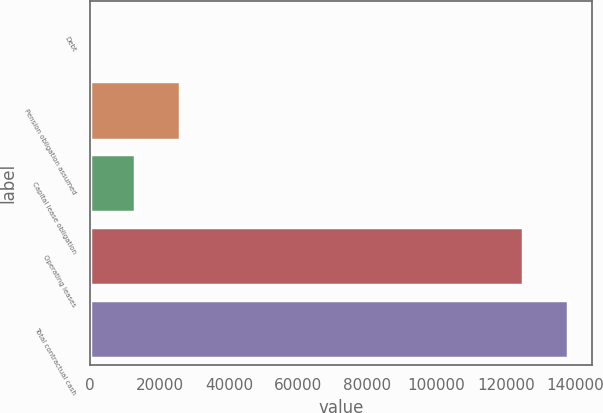<chart> <loc_0><loc_0><loc_500><loc_500><bar_chart><fcel>Debt<fcel>Pension obligation assumed<fcel>Capital lease obligation<fcel>Operating leases<fcel>Total contractual cash<nl><fcel>91<fcel>26019<fcel>13055<fcel>124945<fcel>137909<nl></chart> 